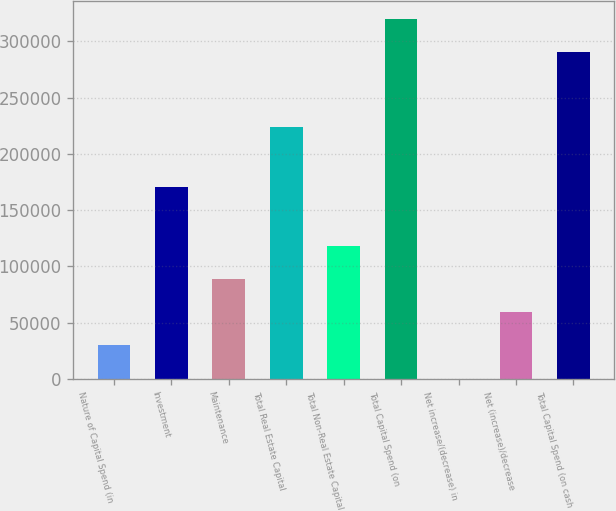<chart> <loc_0><loc_0><loc_500><loc_500><bar_chart><fcel>Nature of Capital Spend (in<fcel>Investment<fcel>Maintenance<fcel>Total Real Estate Capital<fcel>Total Non-Real Estate Capital<fcel>Total Capital Spend (on<fcel>Net increase/(decrease) in<fcel>Net (increase)/decrease<fcel>Total Capital Spend (on cash<nl><fcel>29818.6<fcel>170742<fcel>88731.8<fcel>223568<fcel>118188<fcel>319706<fcel>362<fcel>59275.2<fcel>290249<nl></chart> 